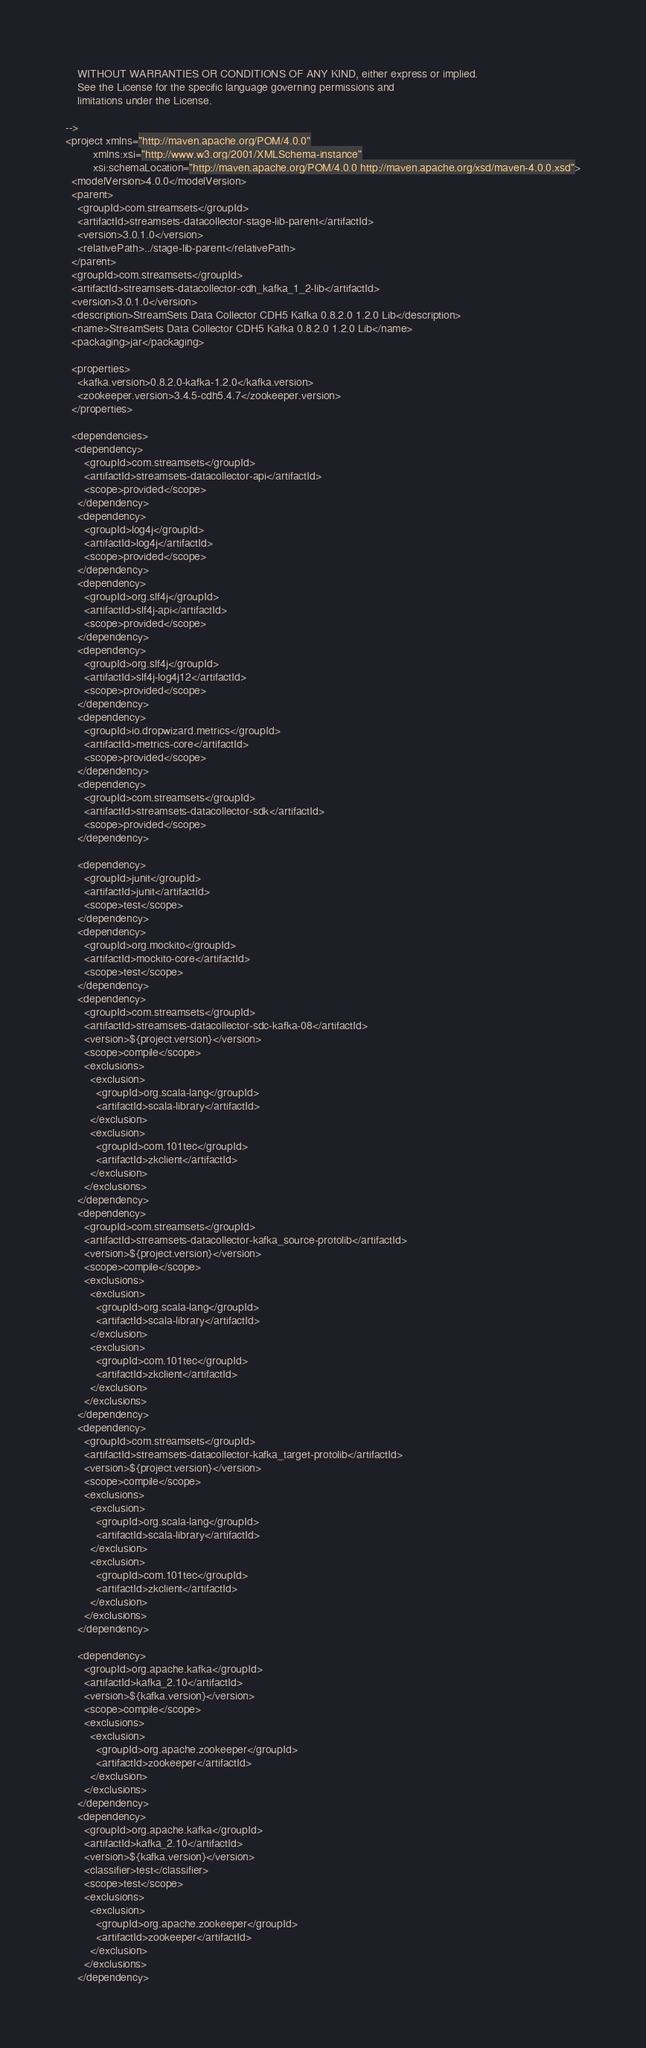Convert code to text. <code><loc_0><loc_0><loc_500><loc_500><_XML_>    WITHOUT WARRANTIES OR CONDITIONS OF ANY KIND, either express or implied.
    See the License for the specific language governing permissions and
    limitations under the License.

-->
<project xmlns="http://maven.apache.org/POM/4.0.0"
         xmlns:xsi="http://www.w3.org/2001/XMLSchema-instance"
         xsi:schemaLocation="http://maven.apache.org/POM/4.0.0 http://maven.apache.org/xsd/maven-4.0.0.xsd">
  <modelVersion>4.0.0</modelVersion>
  <parent>
    <groupId>com.streamsets</groupId>
    <artifactId>streamsets-datacollector-stage-lib-parent</artifactId>
    <version>3.0.1.0</version>
    <relativePath>../stage-lib-parent</relativePath>
  </parent>
  <groupId>com.streamsets</groupId>
  <artifactId>streamsets-datacollector-cdh_kafka_1_2-lib</artifactId>
  <version>3.0.1.0</version>
  <description>StreamSets Data Collector CDH5 Kafka 0.8.2.0 1.2.0 Lib</description>
  <name>StreamSets Data Collector CDH5 Kafka 0.8.2.0 1.2.0 Lib</name>
  <packaging>jar</packaging>

  <properties>
    <kafka.version>0.8.2.0-kafka-1.2.0</kafka.version>
    <zookeeper.version>3.4.5-cdh5.4.7</zookeeper.version>
  </properties>

  <dependencies>
   <dependency>
      <groupId>com.streamsets</groupId>
      <artifactId>streamsets-datacollector-api</artifactId>
      <scope>provided</scope>
    </dependency>
    <dependency>
      <groupId>log4j</groupId>
      <artifactId>log4j</artifactId>
      <scope>provided</scope>
    </dependency>
    <dependency>
      <groupId>org.slf4j</groupId>
      <artifactId>slf4j-api</artifactId>
      <scope>provided</scope>
    </dependency>
    <dependency>
      <groupId>org.slf4j</groupId>
      <artifactId>slf4j-log4j12</artifactId>
      <scope>provided</scope>
    </dependency>
    <dependency>
      <groupId>io.dropwizard.metrics</groupId>
      <artifactId>metrics-core</artifactId>
      <scope>provided</scope>
    </dependency>
    <dependency>
      <groupId>com.streamsets</groupId>
      <artifactId>streamsets-datacollector-sdk</artifactId>
      <scope>provided</scope>
    </dependency>

    <dependency>
      <groupId>junit</groupId>
      <artifactId>junit</artifactId>
      <scope>test</scope>
    </dependency>
    <dependency>
      <groupId>org.mockito</groupId>
      <artifactId>mockito-core</artifactId>
      <scope>test</scope>
    </dependency>
    <dependency>
      <groupId>com.streamsets</groupId>
      <artifactId>streamsets-datacollector-sdc-kafka-08</artifactId>
      <version>${project.version}</version>
      <scope>compile</scope>
      <exclusions>
        <exclusion>
          <groupId>org.scala-lang</groupId>
          <artifactId>scala-library</artifactId>
        </exclusion>
        <exclusion>
          <groupId>com.101tec</groupId>
          <artifactId>zkclient</artifactId>
        </exclusion>
      </exclusions>
    </dependency>
    <dependency>
      <groupId>com.streamsets</groupId>
      <artifactId>streamsets-datacollector-kafka_source-protolib</artifactId>
      <version>${project.version}</version>
      <scope>compile</scope>
      <exclusions>
        <exclusion>
          <groupId>org.scala-lang</groupId>
          <artifactId>scala-library</artifactId>
        </exclusion>
        <exclusion>
          <groupId>com.101tec</groupId>
          <artifactId>zkclient</artifactId>
        </exclusion>
      </exclusions>
    </dependency>
    <dependency>
      <groupId>com.streamsets</groupId>
      <artifactId>streamsets-datacollector-kafka_target-protolib</artifactId>
      <version>${project.version}</version>
      <scope>compile</scope>
      <exclusions>
        <exclusion>
          <groupId>org.scala-lang</groupId>
          <artifactId>scala-library</artifactId>
        </exclusion>
        <exclusion>
          <groupId>com.101tec</groupId>
          <artifactId>zkclient</artifactId>
        </exclusion>
      </exclusions>
    </dependency>

    <dependency>
      <groupId>org.apache.kafka</groupId>
      <artifactId>kafka_2.10</artifactId>
      <version>${kafka.version}</version>
      <scope>compile</scope>
      <exclusions>
        <exclusion>
          <groupId>org.apache.zookeeper</groupId>
          <artifactId>zookeeper</artifactId>
        </exclusion>
      </exclusions>
    </dependency>
    <dependency>
      <groupId>org.apache.kafka</groupId>
      <artifactId>kafka_2.10</artifactId>
      <version>${kafka.version}</version>
      <classifier>test</classifier>
      <scope>test</scope>
      <exclusions>
        <exclusion>
          <groupId>org.apache.zookeeper</groupId>
          <artifactId>zookeeper</artifactId>
        </exclusion>
      </exclusions>
    </dependency></code> 